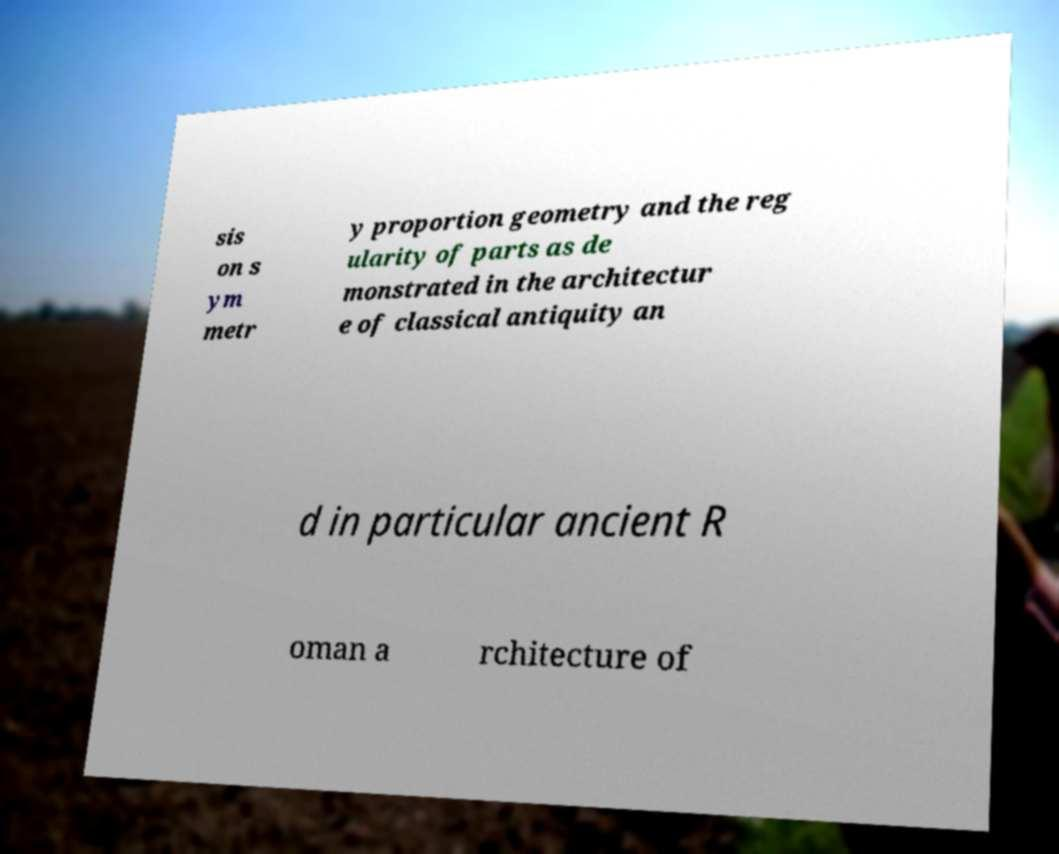Please identify and transcribe the text found in this image. sis on s ym metr y proportion geometry and the reg ularity of parts as de monstrated in the architectur e of classical antiquity an d in particular ancient R oman a rchitecture of 